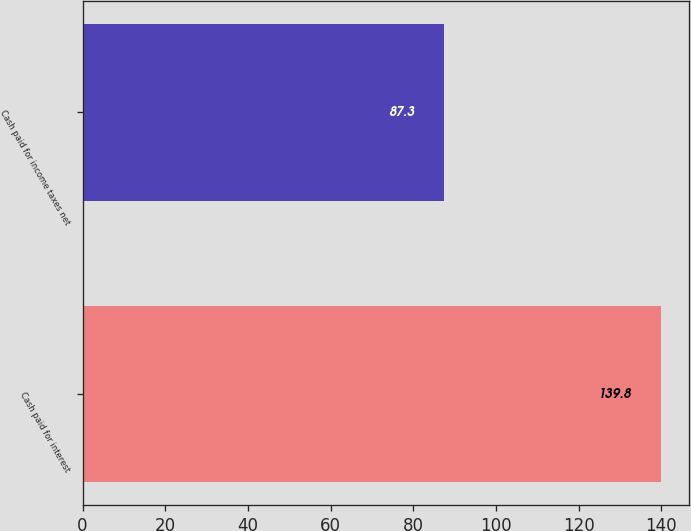<chart> <loc_0><loc_0><loc_500><loc_500><bar_chart><fcel>Cash paid for interest<fcel>Cash paid for income taxes net<nl><fcel>139.8<fcel>87.3<nl></chart> 